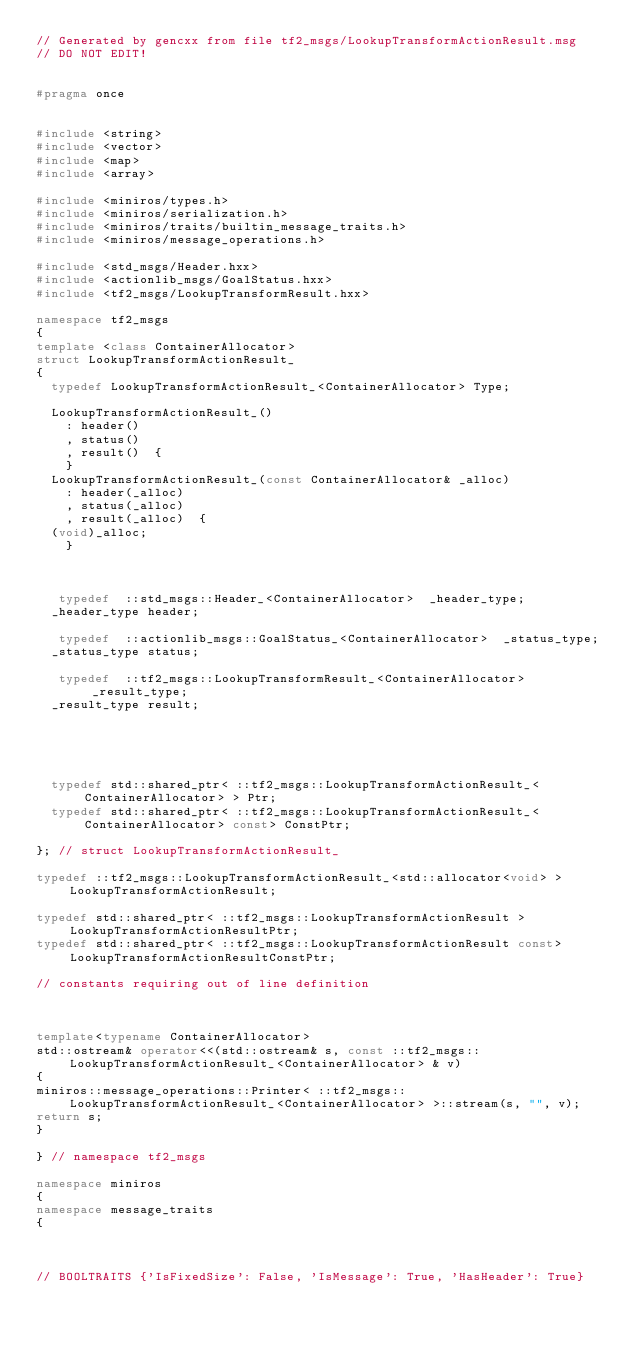Convert code to text. <code><loc_0><loc_0><loc_500><loc_500><_C++_>// Generated by gencxx from file tf2_msgs/LookupTransformActionResult.msg
// DO NOT EDIT!


#pragma once


#include <string>
#include <vector>
#include <map>
#include <array>

#include <miniros/types.h>
#include <miniros/serialization.h>
#include <miniros/traits/builtin_message_traits.h>
#include <miniros/message_operations.h>

#include <std_msgs/Header.hxx>
#include <actionlib_msgs/GoalStatus.hxx>
#include <tf2_msgs/LookupTransformResult.hxx>

namespace tf2_msgs
{
template <class ContainerAllocator>
struct LookupTransformActionResult_
{
  typedef LookupTransformActionResult_<ContainerAllocator> Type;

  LookupTransformActionResult_()
    : header()
    , status()
    , result()  {
    }
  LookupTransformActionResult_(const ContainerAllocator& _alloc)
    : header(_alloc)
    , status(_alloc)
    , result(_alloc)  {
  (void)_alloc;
    }



   typedef  ::std_msgs::Header_<ContainerAllocator>  _header_type;
  _header_type header;

   typedef  ::actionlib_msgs::GoalStatus_<ContainerAllocator>  _status_type;
  _status_type status;

   typedef  ::tf2_msgs::LookupTransformResult_<ContainerAllocator>  _result_type;
  _result_type result;





  typedef std::shared_ptr< ::tf2_msgs::LookupTransformActionResult_<ContainerAllocator> > Ptr;
  typedef std::shared_ptr< ::tf2_msgs::LookupTransformActionResult_<ContainerAllocator> const> ConstPtr;

}; // struct LookupTransformActionResult_

typedef ::tf2_msgs::LookupTransformActionResult_<std::allocator<void> > LookupTransformActionResult;

typedef std::shared_ptr< ::tf2_msgs::LookupTransformActionResult > LookupTransformActionResultPtr;
typedef std::shared_ptr< ::tf2_msgs::LookupTransformActionResult const> LookupTransformActionResultConstPtr;

// constants requiring out of line definition



template<typename ContainerAllocator>
std::ostream& operator<<(std::ostream& s, const ::tf2_msgs::LookupTransformActionResult_<ContainerAllocator> & v)
{
miniros::message_operations::Printer< ::tf2_msgs::LookupTransformActionResult_<ContainerAllocator> >::stream(s, "", v);
return s;
}

} // namespace tf2_msgs

namespace miniros
{
namespace message_traits
{



// BOOLTRAITS {'IsFixedSize': False, 'IsMessage': True, 'HasHeader': True}</code> 